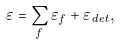<formula> <loc_0><loc_0><loc_500><loc_500>\varepsilon = \sum _ { f } \varepsilon _ { f } + \varepsilon _ { d e t } ,</formula> 